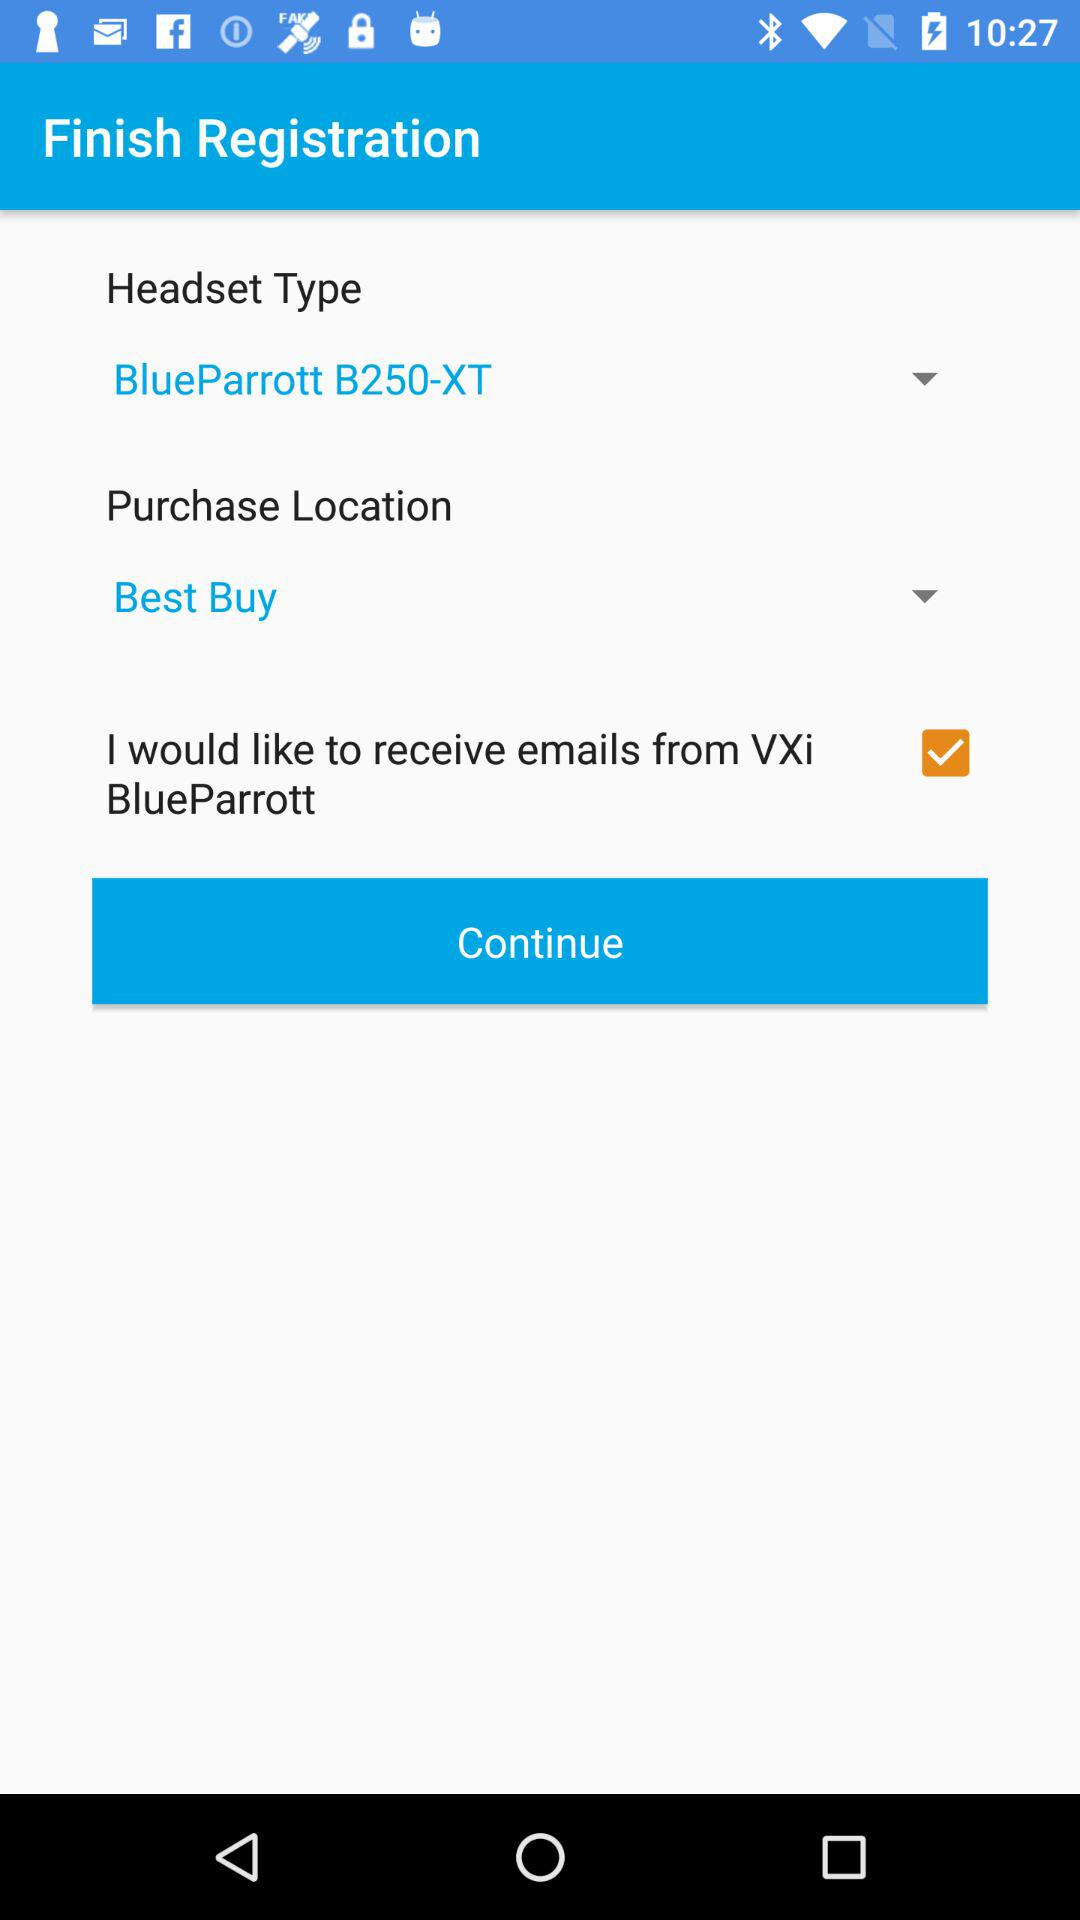Which option is checked? The checked option is "I would like to receive emails from VXi BlueParrott". 